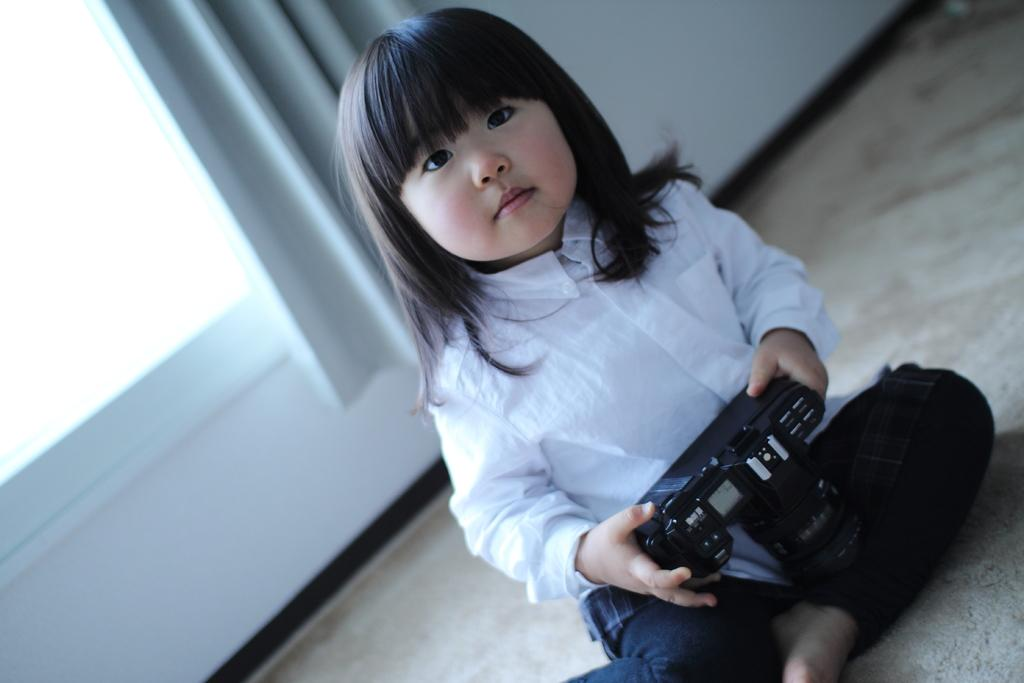What is the main subject of the image? The main subject of the image is a kid. What is the kid doing in the image? The kid is sitting on the floor. What object is the kid holding in the image? The kid is holding a remote control. What can be seen in the background of the image? There is a window in the background of the image. What type of window treatment is present in the image? There is a curtain associated with the window. What type of shoe is the person wearing in the image? There is no person present in the image, only a kid. Can you describe the dock that is visible in the image? There is no dock present in the image. 